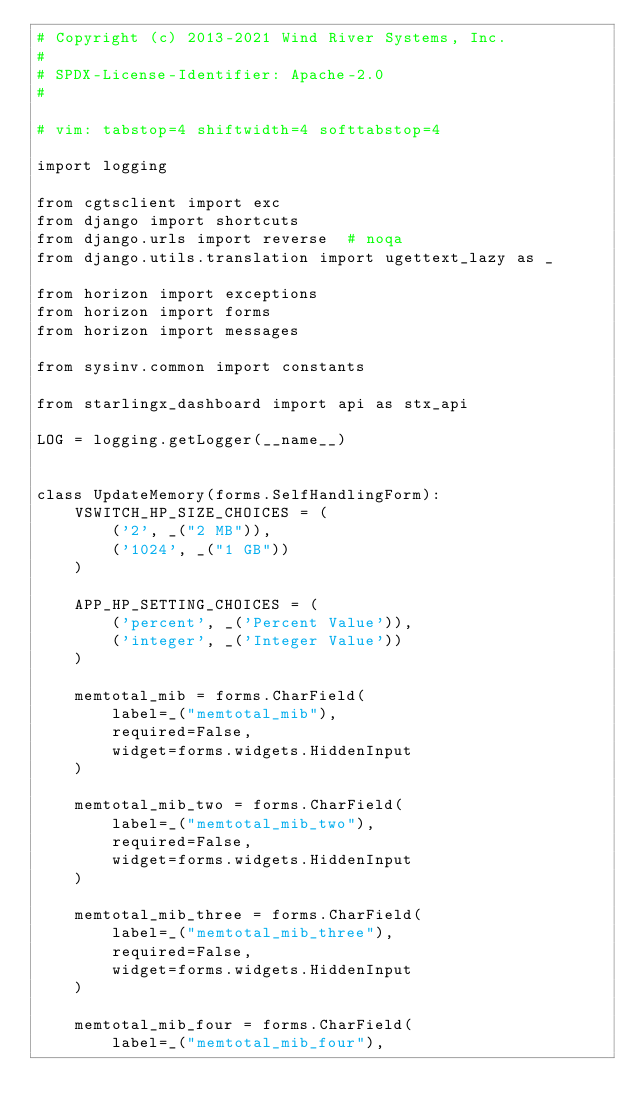Convert code to text. <code><loc_0><loc_0><loc_500><loc_500><_Python_># Copyright (c) 2013-2021 Wind River Systems, Inc.
#
# SPDX-License-Identifier: Apache-2.0
#

# vim: tabstop=4 shiftwidth=4 softtabstop=4

import logging

from cgtsclient import exc
from django import shortcuts
from django.urls import reverse  # noqa
from django.utils.translation import ugettext_lazy as _

from horizon import exceptions
from horizon import forms
from horizon import messages

from sysinv.common import constants

from starlingx_dashboard import api as stx_api

LOG = logging.getLogger(__name__)


class UpdateMemory(forms.SelfHandlingForm):
    VSWITCH_HP_SIZE_CHOICES = (
        ('2', _("2 MB")),
        ('1024', _("1 GB"))
    )

    APP_HP_SETTING_CHOICES = (
        ('percent', _('Percent Value')),
        ('integer', _('Integer Value'))
    )

    memtotal_mib = forms.CharField(
        label=_("memtotal_mib"),
        required=False,
        widget=forms.widgets.HiddenInput
    )

    memtotal_mib_two = forms.CharField(
        label=_("memtotal_mib_two"),
        required=False,
        widget=forms.widgets.HiddenInput
    )

    memtotal_mib_three = forms.CharField(
        label=_("memtotal_mib_three"),
        required=False,
        widget=forms.widgets.HiddenInput
    )

    memtotal_mib_four = forms.CharField(
        label=_("memtotal_mib_four"),</code> 